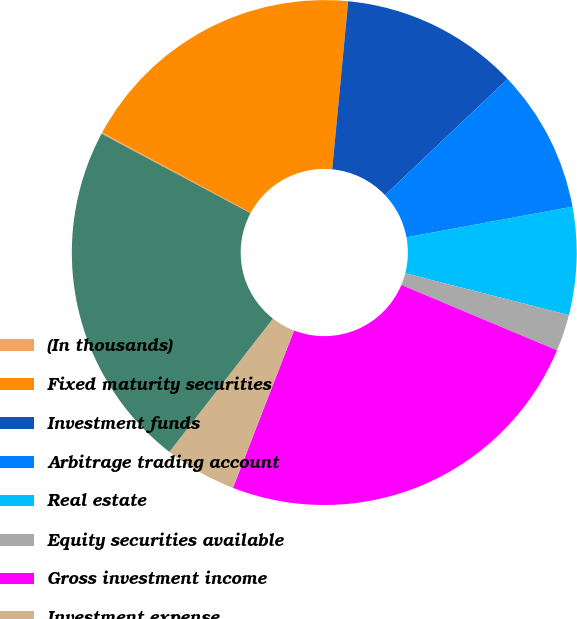Convert chart to OTSL. <chart><loc_0><loc_0><loc_500><loc_500><pie_chart><fcel>(In thousands)<fcel>Fixed maturity securities<fcel>Investment funds<fcel>Arbitrage trading account<fcel>Real estate<fcel>Equity securities available<fcel>Gross investment income<fcel>Investment expense<fcel>Net investment income<nl><fcel>0.09%<fcel>18.62%<fcel>11.42%<fcel>9.16%<fcel>6.89%<fcel>2.35%<fcel>24.56%<fcel>4.62%<fcel>22.29%<nl></chart> 